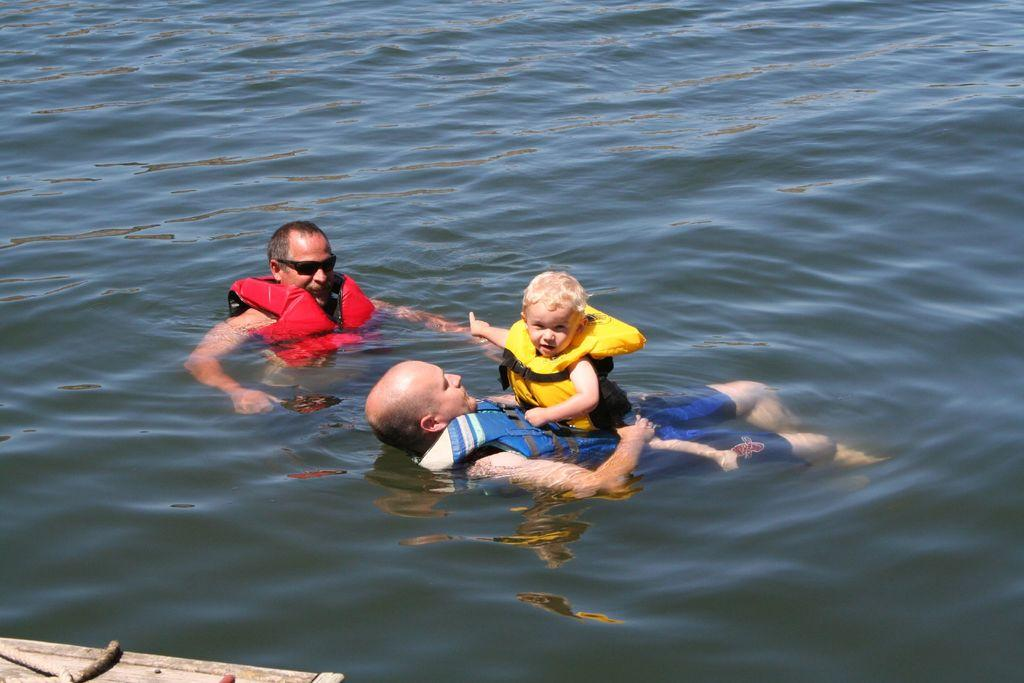How many people are in the image? There are three individuals in the image. Can you describe the activities of the people in the image? All three individuals are swimming in the water. What is the age group of the third person in the image? The third person is a kid. What type of sticks can be seen floating in the soup in the image? There is no soup or sticks present in the image; it features two men and a kid swimming in the water. 